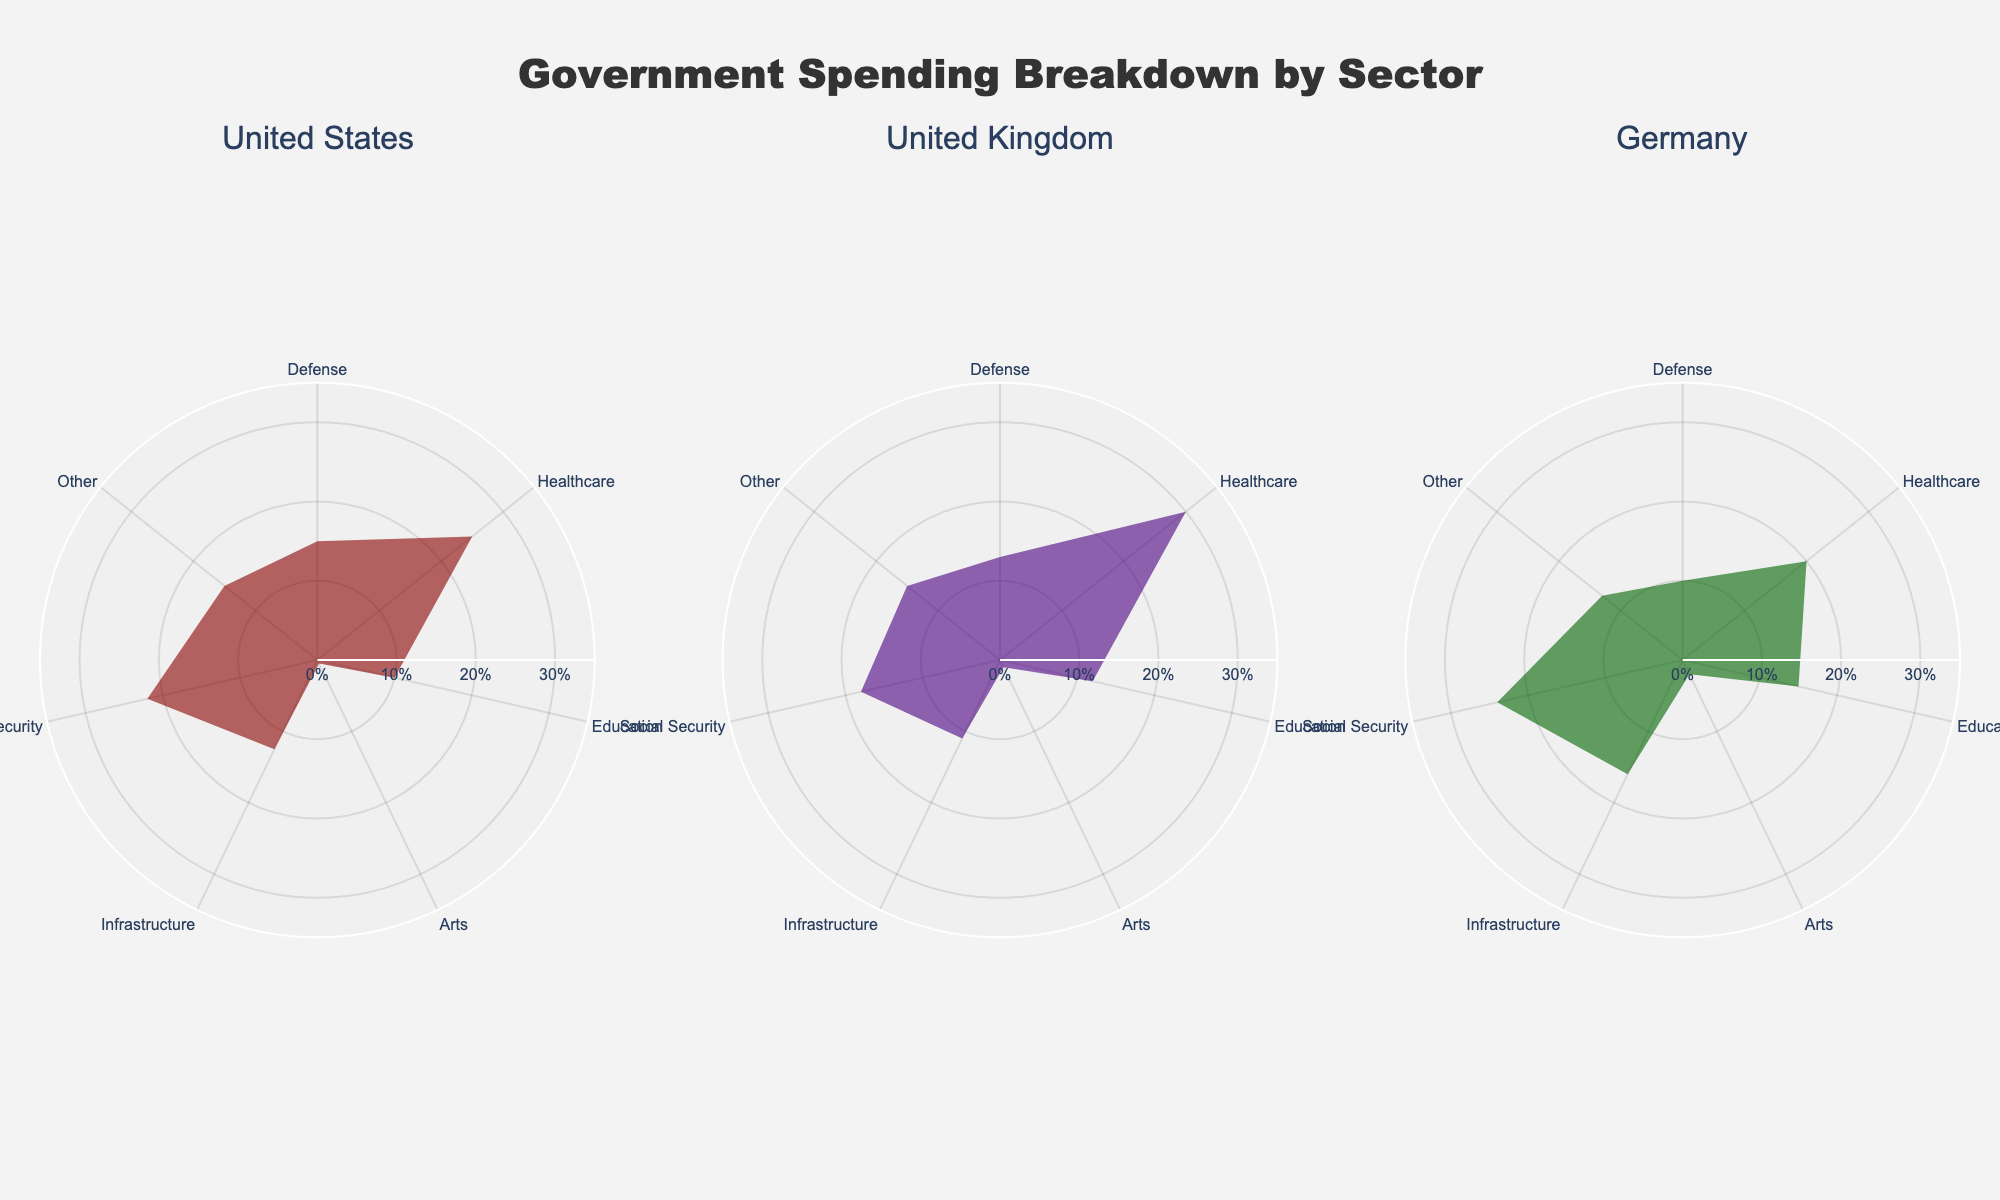What is the largest sector in the United States' government spending? The largest sector in the United States' government spending is Healthcare, occupying 25% of the budget, as seen by the highest percentage value within the United States subplot.
Answer: Healthcare What percentage of the UK's government spending is on Arts? By looking at the United Kingdom subplot in the figure, we can see that the percentage allocated to Arts is marked at 1.0%.
Answer: 1.0% Which country spends the least percentage on Defense? By comparing the Defense percentages in all three subplots, we find that Germany has the lowest Defense spending at 10%.
Answer: Germany How does the percentage of spending on Arts in Germany compare to that in the United States? Germany spends 2% on Arts while the United States spends 0.5%. By subtracting 0.5 from 2, we find that Germany spends 1.5% more.
Answer: 1.5% more What is the total percentage spent on Social Security in the United States and the United Kingdom combined? The United States spends 22% and the United Kingdom spends 18% on Social Security. Adding these together, 22 + 18, gives a total of 40%.
Answer: 40% Calculate the average spending on Education across all three countries. The percentages for Education in the United States, United Kingdom, and Germany are 10%, 12%, and 15%, respectively. The average is calculated by summing these values and dividing by 3: (10 + 12 + 15) / 3 = 12.33%.
Answer: 12.33% Between Healthcare and Infrastructure, which sector receives more funding in each country? In the United States, Healthcare (25%) exceeds Infrastructure (12.5%). In the United Kingdom, Healthcare (30%) exceeds Infrastructure (11%). In Germany, Healthcare (20%) is less than Infrastructure (16%). Therefore, in both the United States and the United Kingdom, Healthcare receives more, while in Germany, Infrastructure receives more.
Answer: Healthcare in US and UK, Infrastructure in Germany Is the proportion of spending on "Other" the same for all three countries? By examining each subplot, it is visible that the spending on "Other" is 15% for both the United States and the United Kingdom, and 13% for Germany. Since these values are not all the same, the answer is no.
Answer: No 